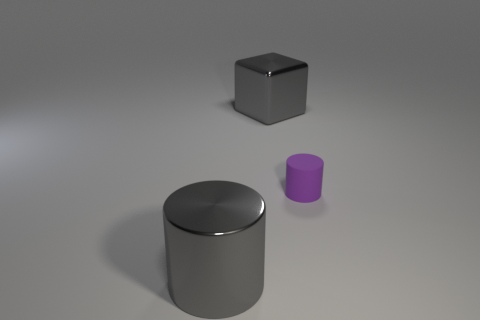Is there any other thing that is the same size as the purple cylinder?
Your answer should be compact. No. There is a purple thing that is behind the shiny cylinder that is in front of the gray metallic thing behind the big gray cylinder; what is it made of?
Offer a terse response. Rubber. Are there any rubber things of the same color as the large metallic cylinder?
Ensure brevity in your answer.  No. Are there fewer objects that are in front of the big gray cylinder than tiny rubber objects?
Keep it short and to the point. Yes. There is a gray object behind the purple cylinder; is it the same size as the purple object?
Provide a short and direct response. No. How many objects are in front of the large block and behind the big cylinder?
Provide a succinct answer. 1. There is a metallic thing that is behind the metal thing that is in front of the purple rubber cylinder; how big is it?
Give a very brief answer. Large. Are there fewer tiny objects in front of the gray shiny cylinder than small purple objects that are in front of the tiny purple object?
Ensure brevity in your answer.  No. There is a cylinder that is left of the large gray block; does it have the same color as the big object that is behind the small purple matte object?
Your response must be concise. Yes. The object that is behind the metallic cylinder and on the left side of the rubber thing is made of what material?
Provide a succinct answer. Metal. 